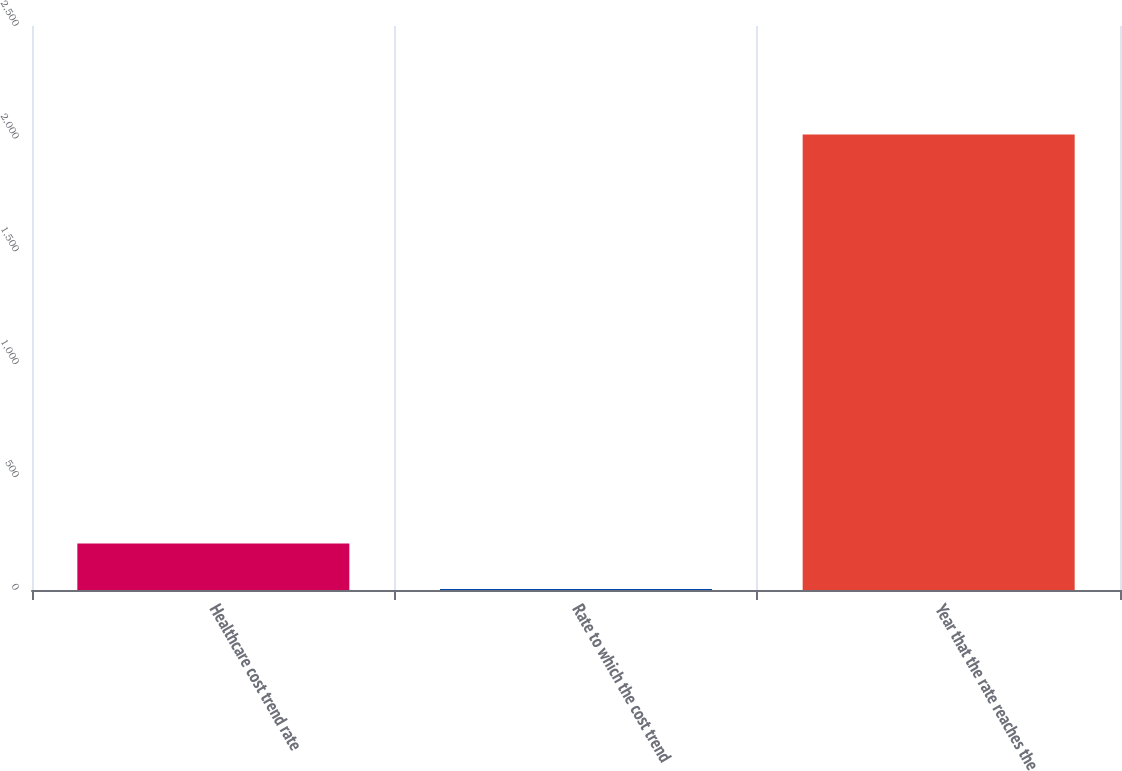Convert chart. <chart><loc_0><loc_0><loc_500><loc_500><bar_chart><fcel>Healthcare cost trend rate<fcel>Rate to which the cost trend<fcel>Year that the rate reaches the<nl><fcel>205.95<fcel>4.5<fcel>2019<nl></chart> 